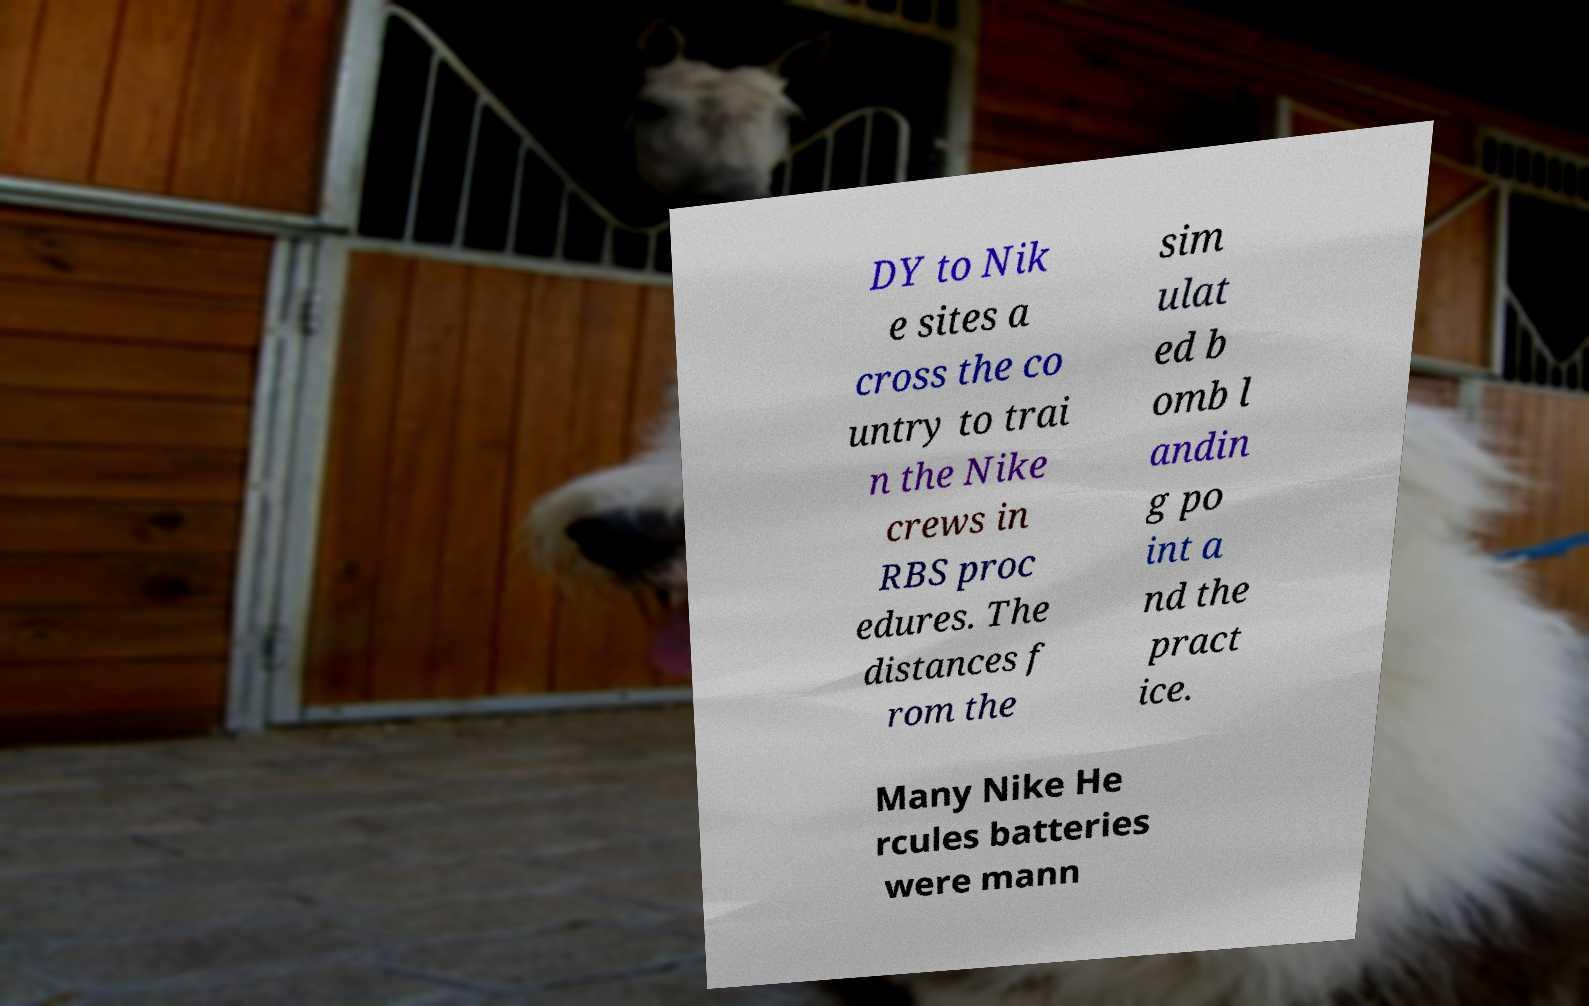For documentation purposes, I need the text within this image transcribed. Could you provide that? DY to Nik e sites a cross the co untry to trai n the Nike crews in RBS proc edures. The distances f rom the sim ulat ed b omb l andin g po int a nd the pract ice. Many Nike He rcules batteries were mann 